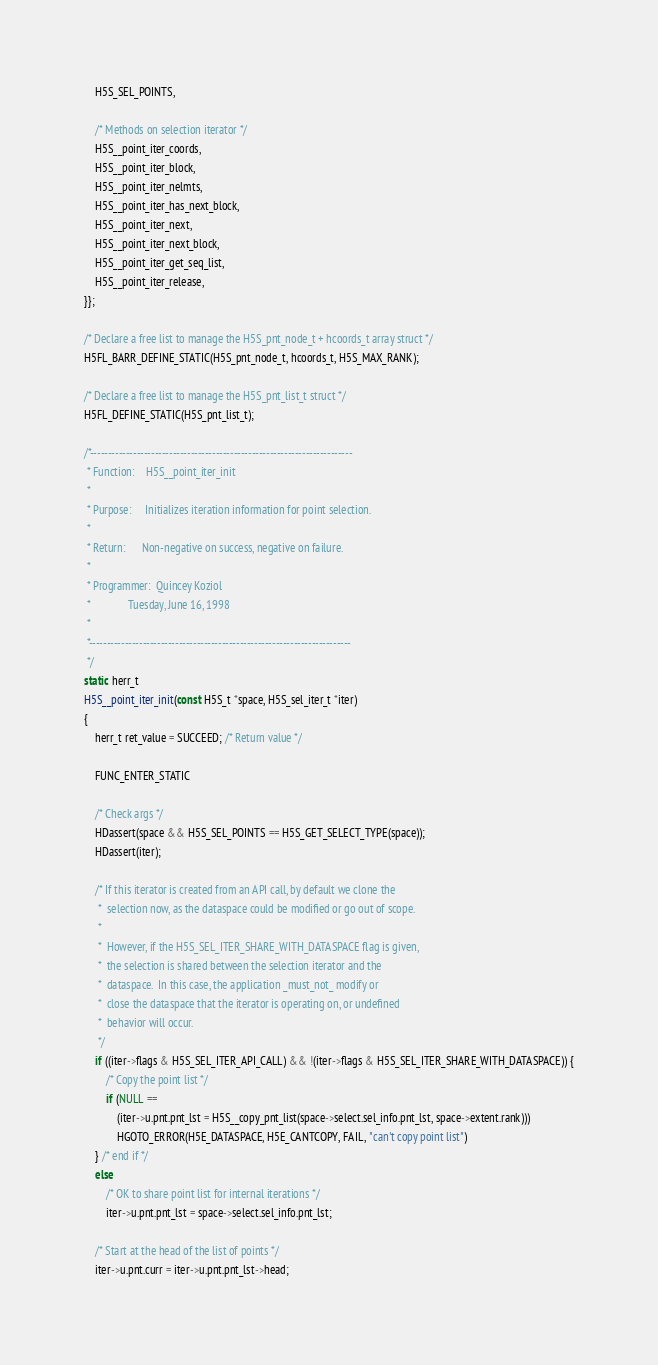Convert code to text. <code><loc_0><loc_0><loc_500><loc_500><_C_>    H5S_SEL_POINTS,

    /* Methods on selection iterator */
    H5S__point_iter_coords,
    H5S__point_iter_block,
    H5S__point_iter_nelmts,
    H5S__point_iter_has_next_block,
    H5S__point_iter_next,
    H5S__point_iter_next_block,
    H5S__point_iter_get_seq_list,
    H5S__point_iter_release,
}};

/* Declare a free list to manage the H5S_pnt_node_t + hcoords_t array struct */
H5FL_BARR_DEFINE_STATIC(H5S_pnt_node_t, hcoords_t, H5S_MAX_RANK);

/* Declare a free list to manage the H5S_pnt_list_t struct */
H5FL_DEFINE_STATIC(H5S_pnt_list_t);

/*-------------------------------------------------------------------------
 * Function:    H5S__point_iter_init
 *
 * Purpose:     Initializes iteration information for point selection.
 *
 * Return:      Non-negative on success, negative on failure.
 *
 * Programmer:  Quincey Koziol
 *              Tuesday, June 16, 1998
 *
 *-------------------------------------------------------------------------
 */
static herr_t
H5S__point_iter_init(const H5S_t *space, H5S_sel_iter_t *iter)
{
    herr_t ret_value = SUCCEED; /* Return value */

    FUNC_ENTER_STATIC

    /* Check args */
    HDassert(space && H5S_SEL_POINTS == H5S_GET_SELECT_TYPE(space));
    HDassert(iter);

    /* If this iterator is created from an API call, by default we clone the
     *  selection now, as the dataspace could be modified or go out of scope.
     *
     *  However, if the H5S_SEL_ITER_SHARE_WITH_DATASPACE flag is given,
     *  the selection is shared between the selection iterator and the
     *  dataspace.  In this case, the application _must_not_ modify or
     *  close the dataspace that the iterator is operating on, or undefined
     *  behavior will occur.
     */
    if ((iter->flags & H5S_SEL_ITER_API_CALL) && !(iter->flags & H5S_SEL_ITER_SHARE_WITH_DATASPACE)) {
        /* Copy the point list */
        if (NULL ==
            (iter->u.pnt.pnt_lst = H5S__copy_pnt_list(space->select.sel_info.pnt_lst, space->extent.rank)))
            HGOTO_ERROR(H5E_DATASPACE, H5E_CANTCOPY, FAIL, "can't copy point list")
    } /* end if */
    else
        /* OK to share point list for internal iterations */
        iter->u.pnt.pnt_lst = space->select.sel_info.pnt_lst;

    /* Start at the head of the list of points */
    iter->u.pnt.curr = iter->u.pnt.pnt_lst->head;
</code> 